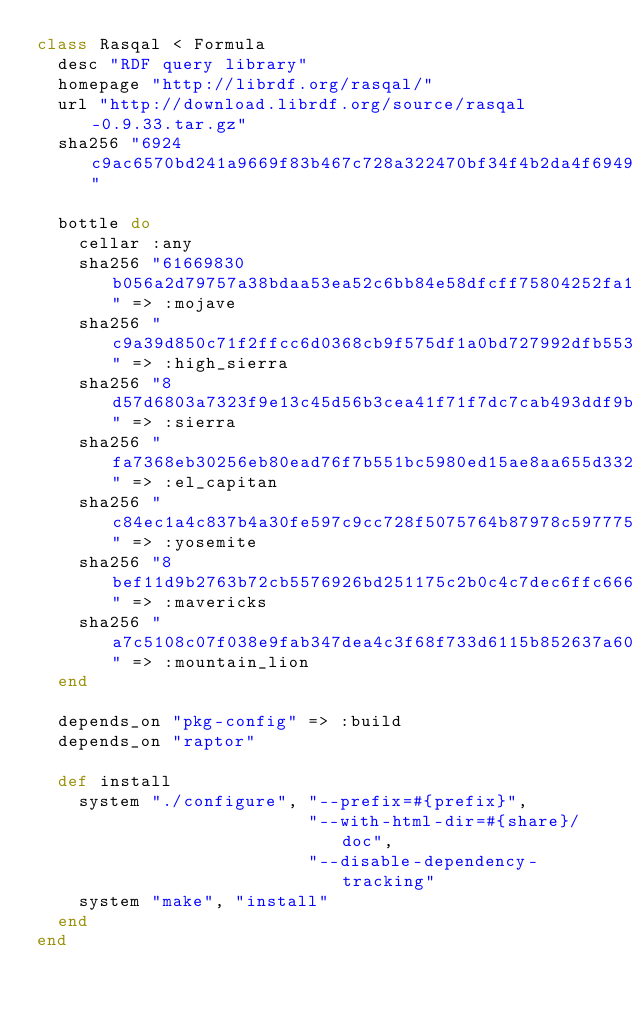<code> <loc_0><loc_0><loc_500><loc_500><_Ruby_>class Rasqal < Formula
  desc "RDF query library"
  homepage "http://librdf.org/rasqal/"
  url "http://download.librdf.org/source/rasqal-0.9.33.tar.gz"
  sha256 "6924c9ac6570bd241a9669f83b467c728a322470bf34f4b2da4f69492ccfd97c"

  bottle do
    cellar :any
    sha256 "61669830b056a2d79757a38bdaa53ea52c6bb84e58dfcff75804252fa12c752e" => :mojave
    sha256 "c9a39d850c71f2ffcc6d0368cb9f575df1a0bd727992dfb553baccc8ecec97ce" => :high_sierra
    sha256 "8d57d6803a7323f9e13c45d56b3cea41f71f7dc7cab493ddf9b34d0a2a6b68f5" => :sierra
    sha256 "fa7368eb30256eb80ead76f7b551bc5980ed15ae8aa655d332a200edb073c2a3" => :el_capitan
    sha256 "c84ec1a4c837b4a30fe597c9cc728f5075764b87978c5977757e2836db3eca0b" => :yosemite
    sha256 "8bef11d9b2763b72cb5576926bd251175c2b0c4c7dec6ffc666f98720341ba27" => :mavericks
    sha256 "a7c5108c07f038e9fab347dea4c3f68f733d6115b852637a60192d06cf7c7eb2" => :mountain_lion
  end

  depends_on "pkg-config" => :build
  depends_on "raptor"

  def install
    system "./configure", "--prefix=#{prefix}",
                          "--with-html-dir=#{share}/doc",
                          "--disable-dependency-tracking"
    system "make", "install"
  end
end
</code> 